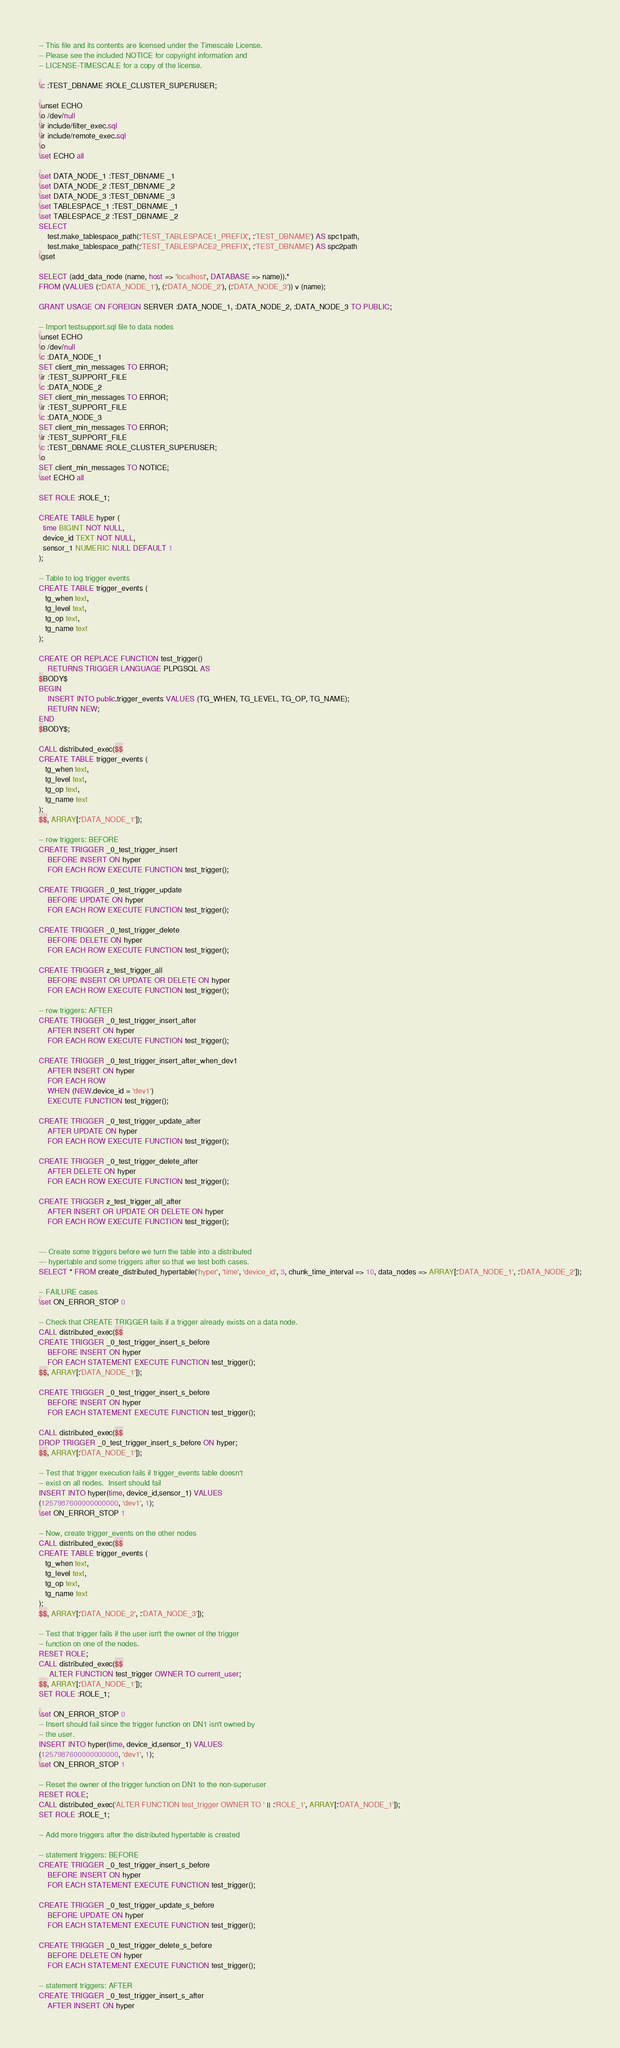Convert code to text. <code><loc_0><loc_0><loc_500><loc_500><_SQL_>-- This file and its contents are licensed under the Timescale License.
-- Please see the included NOTICE for copyright information and
-- LICENSE-TIMESCALE for a copy of the license.

\c :TEST_DBNAME :ROLE_CLUSTER_SUPERUSER;

\unset ECHO
\o /dev/null
\ir include/filter_exec.sql
\ir include/remote_exec.sql
\o
\set ECHO all

\set DATA_NODE_1 :TEST_DBNAME _1
\set DATA_NODE_2 :TEST_DBNAME _2
\set DATA_NODE_3 :TEST_DBNAME _3
\set TABLESPACE_1 :TEST_DBNAME _1
\set TABLESPACE_2 :TEST_DBNAME _2
SELECT
    test.make_tablespace_path(:'TEST_TABLESPACE1_PREFIX', :'TEST_DBNAME') AS spc1path,
    test.make_tablespace_path(:'TEST_TABLESPACE2_PREFIX', :'TEST_DBNAME') AS spc2path
\gset

SELECT (add_data_node (name, host => 'localhost', DATABASE => name)).*
FROM (VALUES (:'DATA_NODE_1'), (:'DATA_NODE_2'), (:'DATA_NODE_3')) v (name);

GRANT USAGE ON FOREIGN SERVER :DATA_NODE_1, :DATA_NODE_2, :DATA_NODE_3 TO PUBLIC;

-- Import testsupport.sql file to data nodes
\unset ECHO
\o /dev/null
\c :DATA_NODE_1
SET client_min_messages TO ERROR;
\ir :TEST_SUPPORT_FILE
\c :DATA_NODE_2
SET client_min_messages TO ERROR;
\ir :TEST_SUPPORT_FILE
\c :DATA_NODE_3
SET client_min_messages TO ERROR;
\ir :TEST_SUPPORT_FILE
\c :TEST_DBNAME :ROLE_CLUSTER_SUPERUSER;
\o
SET client_min_messages TO NOTICE;
\set ECHO all

SET ROLE :ROLE_1;

CREATE TABLE hyper (
  time BIGINT NOT NULL,
  device_id TEXT NOT NULL,
  sensor_1 NUMERIC NULL DEFAULT 1
);

-- Table to log trigger events
CREATE TABLE trigger_events (
   tg_when text,
   tg_level text,
   tg_op text,
   tg_name text
);
  
CREATE OR REPLACE FUNCTION test_trigger()
    RETURNS TRIGGER LANGUAGE PLPGSQL AS
$BODY$
BEGIN
    INSERT INTO public.trigger_events VALUES (TG_WHEN, TG_LEVEL, TG_OP, TG_NAME);	
    RETURN NEW;
END
$BODY$;

CALL distributed_exec($$
CREATE TABLE trigger_events (
   tg_when text,
   tg_level text,
   tg_op text,
   tg_name text
);
$$, ARRAY[:'DATA_NODE_1']);

-- row triggers: BEFORE
CREATE TRIGGER _0_test_trigger_insert
    BEFORE INSERT ON hyper
    FOR EACH ROW EXECUTE FUNCTION test_trigger();

CREATE TRIGGER _0_test_trigger_update
    BEFORE UPDATE ON hyper
    FOR EACH ROW EXECUTE FUNCTION test_trigger();

CREATE TRIGGER _0_test_trigger_delete
    BEFORE DELETE ON hyper
    FOR EACH ROW EXECUTE FUNCTION test_trigger();

CREATE TRIGGER z_test_trigger_all
    BEFORE INSERT OR UPDATE OR DELETE ON hyper
    FOR EACH ROW EXECUTE FUNCTION test_trigger();

-- row triggers: AFTER
CREATE TRIGGER _0_test_trigger_insert_after
    AFTER INSERT ON hyper
    FOR EACH ROW EXECUTE FUNCTION test_trigger();

CREATE TRIGGER _0_test_trigger_insert_after_when_dev1
    AFTER INSERT ON hyper
    FOR EACH ROW
    WHEN (NEW.device_id = 'dev1')
    EXECUTE FUNCTION test_trigger();

CREATE TRIGGER _0_test_trigger_update_after
    AFTER UPDATE ON hyper
    FOR EACH ROW EXECUTE FUNCTION test_trigger();

CREATE TRIGGER _0_test_trigger_delete_after
    AFTER DELETE ON hyper
    FOR EACH ROW EXECUTE FUNCTION test_trigger();

CREATE TRIGGER z_test_trigger_all_after
    AFTER INSERT OR UPDATE OR DELETE ON hyper
    FOR EACH ROW EXECUTE FUNCTION test_trigger();


--- Create some triggers before we turn the table into a distributed
--- hypertable and some triggers after so that we test both cases.
SELECT * FROM create_distributed_hypertable('hyper', 'time', 'device_id', 3, chunk_time_interval => 10, data_nodes => ARRAY[:'DATA_NODE_1', :'DATA_NODE_2']);

-- FAILURE cases
\set ON_ERROR_STOP 0

-- Check that CREATE TRIGGER fails if a trigger already exists on a data node.
CALL distributed_exec($$
CREATE TRIGGER _0_test_trigger_insert_s_before
    BEFORE INSERT ON hyper
    FOR EACH STATEMENT EXECUTE FUNCTION test_trigger();
$$, ARRAY[:'DATA_NODE_1']);

CREATE TRIGGER _0_test_trigger_insert_s_before
    BEFORE INSERT ON hyper
    FOR EACH STATEMENT EXECUTE FUNCTION test_trigger();

CALL distributed_exec($$
DROP TRIGGER _0_test_trigger_insert_s_before ON hyper;
$$, ARRAY[:'DATA_NODE_1']);

-- Test that trigger execution fails if trigger_events table doesn't
-- exist on all nodes.  Insert should fail
INSERT INTO hyper(time, device_id,sensor_1) VALUES
(1257987600000000000, 'dev1', 1);
\set ON_ERROR_STOP 1

-- Now, create trigger_events on the other nodes
CALL distributed_exec($$
CREATE TABLE trigger_events (
   tg_when text,
   tg_level text,
   tg_op text,
   tg_name text
);
$$, ARRAY[:'DATA_NODE_2', :'DATA_NODE_3']);

-- Test that trigger fails if the user isn't the owner of the trigger
-- function on one of the nodes.
RESET ROLE;
CALL distributed_exec($$
     ALTER FUNCTION test_trigger OWNER TO current_user;
$$, ARRAY[:'DATA_NODE_1']);
SET ROLE :ROLE_1;

\set ON_ERROR_STOP 0
-- Insert should fail since the trigger function on DN1 isn't owned by
-- the user.
INSERT INTO hyper(time, device_id,sensor_1) VALUES
(1257987600000000000, 'dev1', 1);
\set ON_ERROR_STOP 1

-- Reset the owner of the trigger function on DN1 to the non-superuser
RESET ROLE;
CALL distributed_exec('ALTER FUNCTION test_trigger OWNER TO ' || :'ROLE_1', ARRAY[:'DATA_NODE_1']);
SET ROLE :ROLE_1;

-- Add more triggers after the distributed hypertable is created

-- statement triggers: BEFORE
CREATE TRIGGER _0_test_trigger_insert_s_before
    BEFORE INSERT ON hyper
    FOR EACH STATEMENT EXECUTE FUNCTION test_trigger();

CREATE TRIGGER _0_test_trigger_update_s_before
    BEFORE UPDATE ON hyper
    FOR EACH STATEMENT EXECUTE FUNCTION test_trigger();

CREATE TRIGGER _0_test_trigger_delete_s_before
    BEFORE DELETE ON hyper
    FOR EACH STATEMENT EXECUTE FUNCTION test_trigger();

-- statement triggers: AFTER
CREATE TRIGGER _0_test_trigger_insert_s_after
    AFTER INSERT ON hyper</code> 